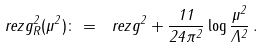Convert formula to latex. <formula><loc_0><loc_0><loc_500><loc_500>\ r e z { g _ { R } ^ { 2 } ( \mu ^ { 2 } ) } \colon = \ r e z { g ^ { 2 } } + \frac { 1 1 } { 2 4 \pi ^ { 2 } } \log \frac { \mu ^ { 2 } } { \Lambda ^ { 2 } } \, .</formula> 